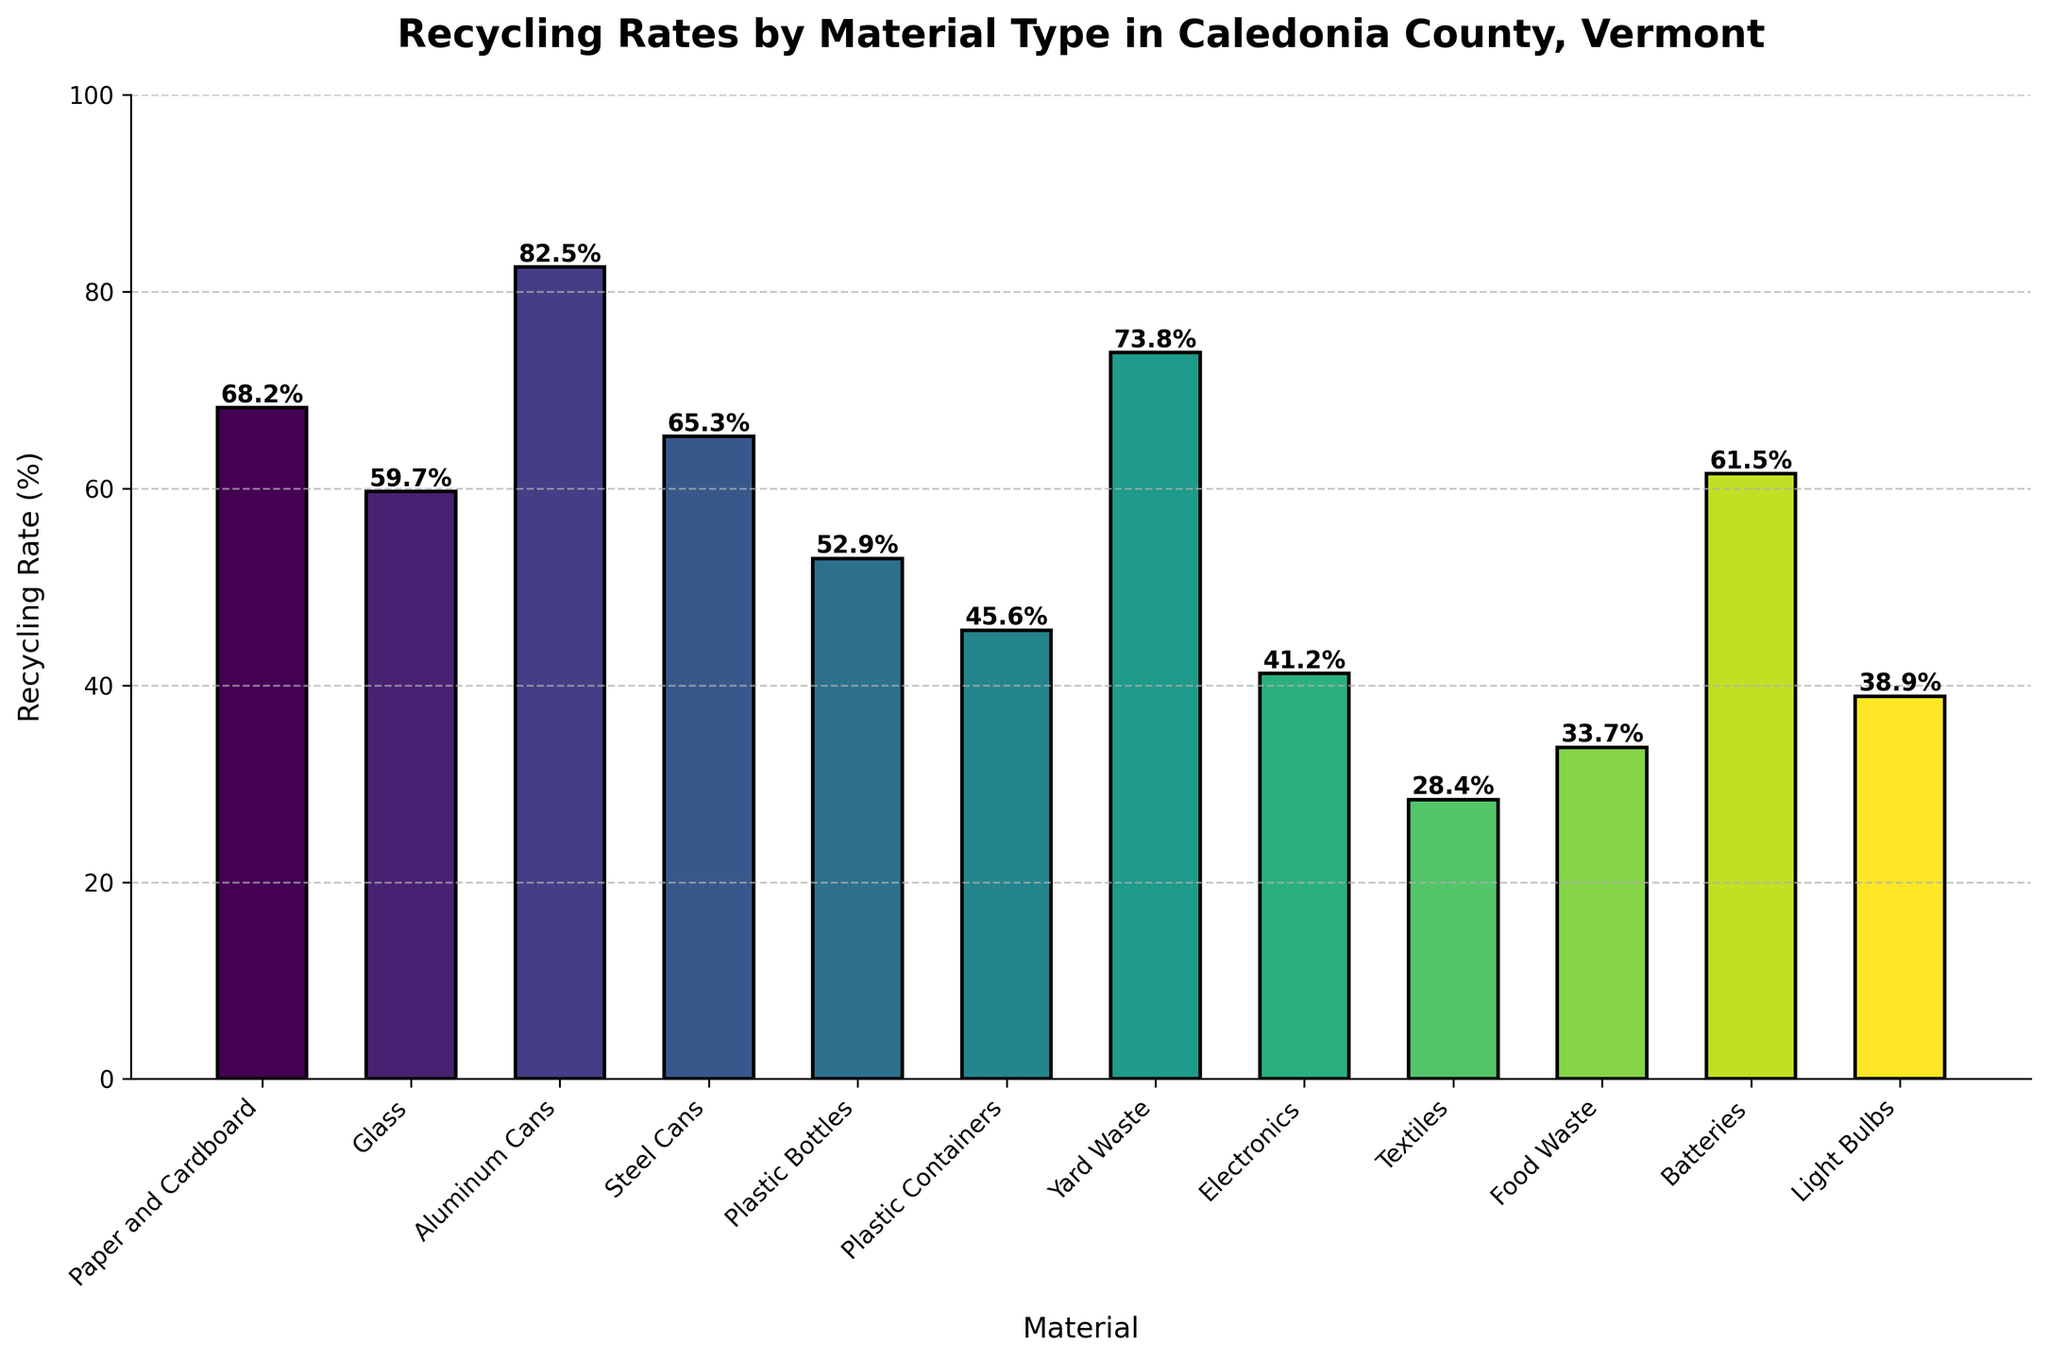what material has the highest recycling rate? Looking at the bars, the tallest bar represents Aluminum Cans with a recycling rate of 82.5%.
Answer: Aluminum Cans compare the recycling rates of paper and cardboard with plastic bottles. which one is higher? Paper and Cardboard have a recycling rate of 68.2%, while Plastic Bottles have a rate of 52.9%. By comparing these numbers, Paper and Cardboard have a higher recycling rate.
Answer: Paper and Cardboard what is the difference in recycling rates between yard waste and textiles? Yard Waste has a recycling rate of 73.8% and Textiles have a rate of 28.4%. The difference is calculated as 73.8% - 28.4%.
Answer: 45.4% what is the average recycling rate of glass, batteries, and light bulbs? Adding up the recycling rates for Glass (59.7%), Batteries (61.5%), and Light Bulbs (38.9%) gives 59.7 + 61.5 + 38.9 = 160.1. Dividing by 3 to find the average: 160.1 / 3 = approximately 53.4%.
Answer: 53.4% which materials have recycling rates lower than 50%? The bars with heights representing recycling rates lower than 50% correspond to Plastic Containers (45.6%), Electronics (41.2%), Textiles (28.4%), Food Waste (33.7%), and Light Bulbs (38.9%).
Answer: Plastic Containers, Electronics, Textiles, Food Waste, Light Bulbs how much higher is the recycling rate for aluminum cans compared to steel cans? The recycling rate for Aluminum Cans is 82.5%, and for Steel Cans, it is 65.3%. The difference is 82.5% - 65.3%.
Answer: 17.2% what is the total recycling rate for materials starting with 'P'? Paper and Cardboard have a rate of 68.2%, Plastic Bottles have 52.9%, and Plastic Containers have 45.6%. Adding them gives 68.2 + 52.9 + 45.6 = 166.7%.
Answer: 166.7% what is the recycling rate range of the materials? The highest recycling rate is for Aluminum Cans (82.5%), and the lowest is for Textiles (28.4%). The range is calculated as 82.5% - 28.4%.
Answer: 54.1% 